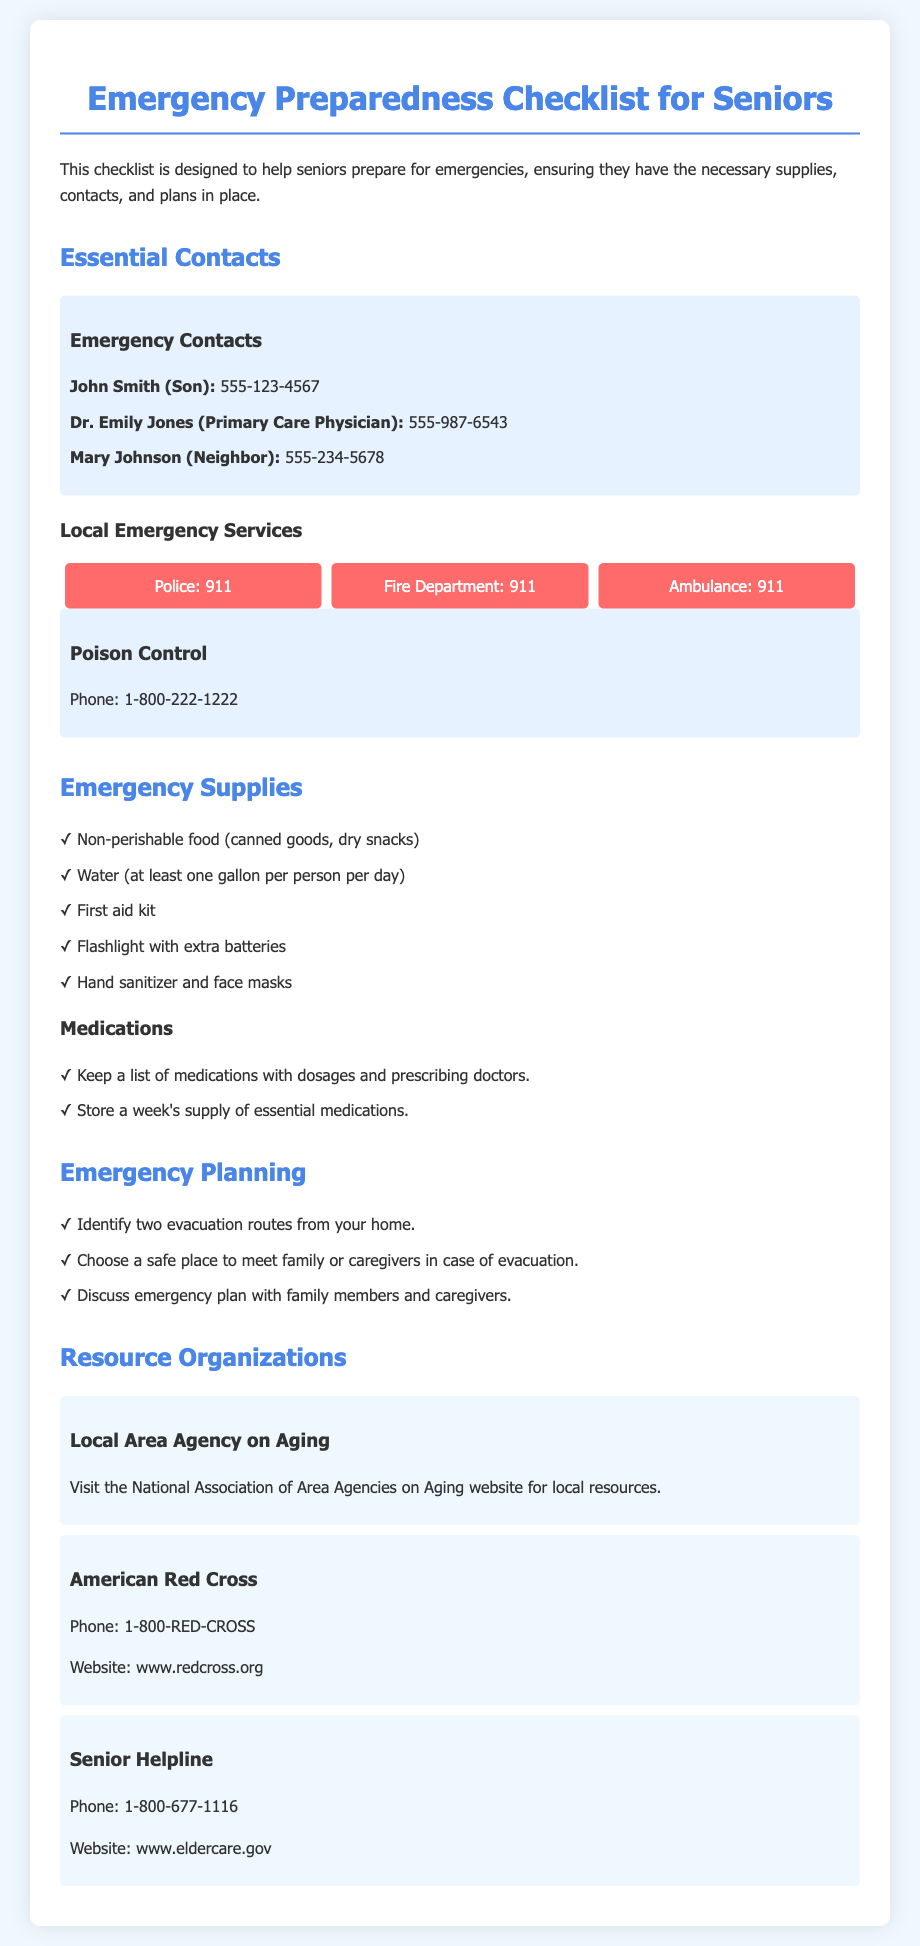What is the primary purpose of the checklist? The document states that the checklist is designed to help seniors prepare for emergencies.
Answer: Prepare for emergencies Who is the primary care physician listed? The document includes Dr. Emily Jones as the primary care physician.
Answer: Dr. Emily Jones What is the phone number for Poison Control? The document provides the Poison Control phone number as 1-800-222-1222.
Answer: 1-800-222-1222 How many evacuation routes should be identified? The document indicates that seniors should identify two evacuation routes.
Answer: Two What organization can be contacted for senior support? The document lists the Senior Helpline as a resource for senior support.
Answer: Senior Helpline What type of food should seniors include in their emergency supplies? The checklist recommends non-perishable food such as canned goods and dry snacks.
Answer: Non-perishable food How many gallons of water should be stored per person per day? The document suggests storing at least one gallon of water per person per day.
Answer: One gallon What is the contact number for the American Red Cross? The document mentions the phone number for the American Red Cross is 1-800-RED-CROSS.
Answer: 1-800-RED-CROSS What is one of the recommended supplies in the emergency kit? The document lists a first aid kit as a recommended supply in the emergency kit.
Answer: First aid kit 